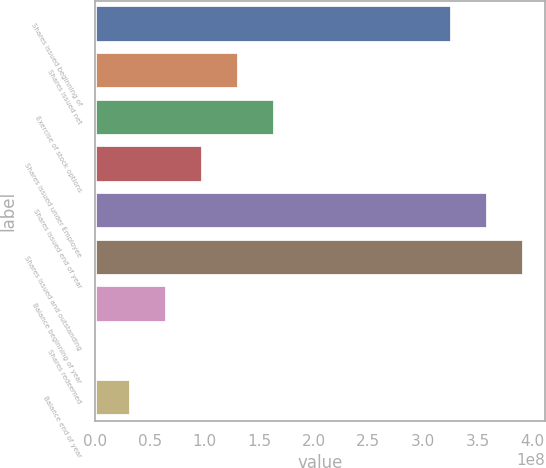<chart> <loc_0><loc_0><loc_500><loc_500><bar_chart><fcel>Shares issued beginning of<fcel>Shares issued net<fcel>Exercise of stock options<fcel>Shares issued under Employee<fcel>Shares issued end of year<fcel>Shares issued and outstanding<fcel>Balance beginning of year<fcel>Shares redeemed<fcel>Balance end of year<nl><fcel>3.26455e+08<fcel>1.31911e+08<fcel>1.64877e+08<fcel>9.89458e+07<fcel>3.59421e+08<fcel>3.92387e+08<fcel>6.59803e+07<fcel>49194<fcel>3.30147e+07<nl></chart> 